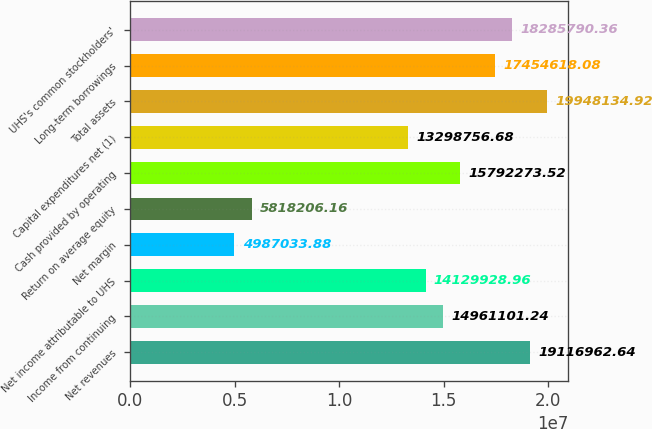<chart> <loc_0><loc_0><loc_500><loc_500><bar_chart><fcel>Net revenues<fcel>Income from continuing<fcel>Net income attributable to UHS<fcel>Net margin<fcel>Return on average equity<fcel>Cash provided by operating<fcel>Capital expenditures net (1)<fcel>Total assets<fcel>Long-term borrowings<fcel>UHS's common stockholders'<nl><fcel>1.9117e+07<fcel>1.49611e+07<fcel>1.41299e+07<fcel>4.98703e+06<fcel>5.81821e+06<fcel>1.57923e+07<fcel>1.32988e+07<fcel>1.99481e+07<fcel>1.74546e+07<fcel>1.82858e+07<nl></chart> 